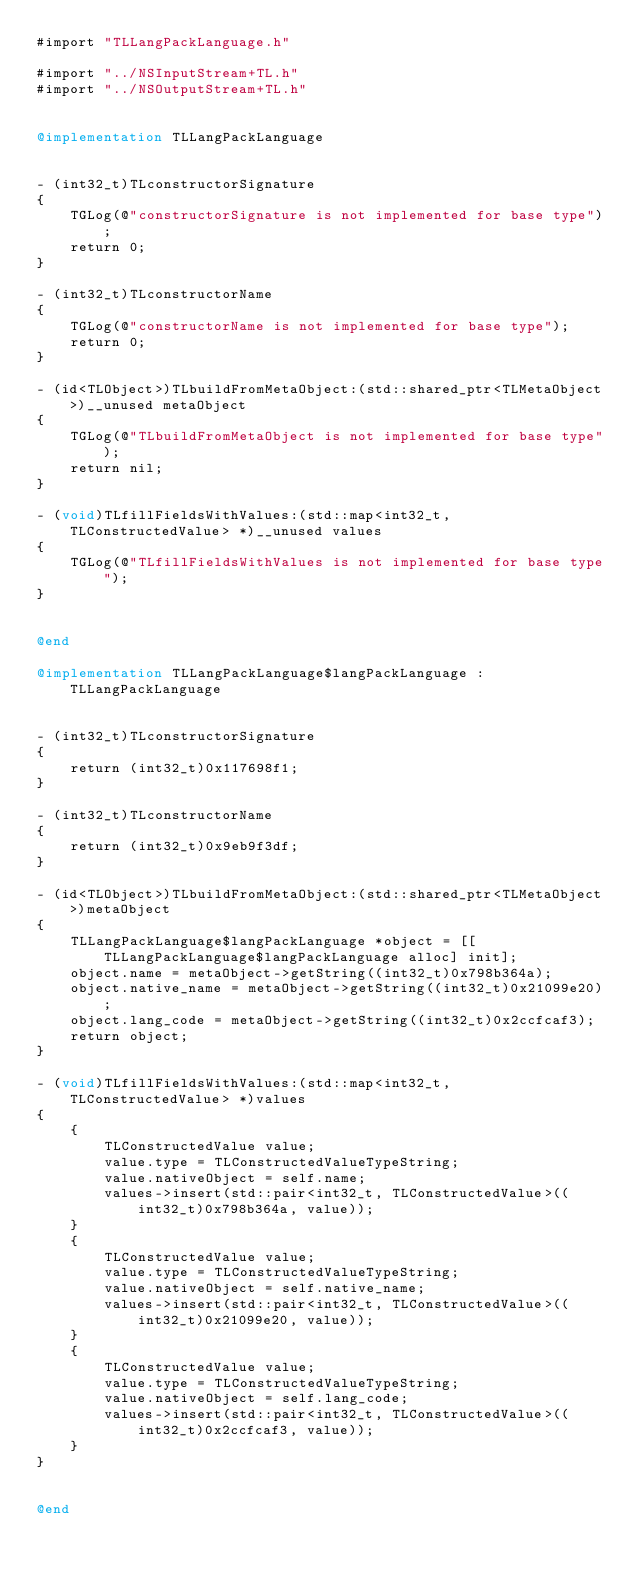Convert code to text. <code><loc_0><loc_0><loc_500><loc_500><_ObjectiveC_>#import "TLLangPackLanguage.h"

#import "../NSInputStream+TL.h"
#import "../NSOutputStream+TL.h"


@implementation TLLangPackLanguage


- (int32_t)TLconstructorSignature
{
    TGLog(@"constructorSignature is not implemented for base type");
    return 0;
}

- (int32_t)TLconstructorName
{
    TGLog(@"constructorName is not implemented for base type");
    return 0;
}

- (id<TLObject>)TLbuildFromMetaObject:(std::shared_ptr<TLMetaObject>)__unused metaObject
{
    TGLog(@"TLbuildFromMetaObject is not implemented for base type");
    return nil;
}

- (void)TLfillFieldsWithValues:(std::map<int32_t, TLConstructedValue> *)__unused values
{
    TGLog(@"TLfillFieldsWithValues is not implemented for base type");
}


@end

@implementation TLLangPackLanguage$langPackLanguage : TLLangPackLanguage


- (int32_t)TLconstructorSignature
{
    return (int32_t)0x117698f1;
}

- (int32_t)TLconstructorName
{
    return (int32_t)0x9eb9f3df;
}

- (id<TLObject>)TLbuildFromMetaObject:(std::shared_ptr<TLMetaObject>)metaObject
{
    TLLangPackLanguage$langPackLanguage *object = [[TLLangPackLanguage$langPackLanguage alloc] init];
    object.name = metaObject->getString((int32_t)0x798b364a);
    object.native_name = metaObject->getString((int32_t)0x21099e20);
    object.lang_code = metaObject->getString((int32_t)0x2ccfcaf3);
    return object;
}

- (void)TLfillFieldsWithValues:(std::map<int32_t, TLConstructedValue> *)values
{
    {
        TLConstructedValue value;
        value.type = TLConstructedValueTypeString;
        value.nativeObject = self.name;
        values->insert(std::pair<int32_t, TLConstructedValue>((int32_t)0x798b364a, value));
    }
    {
        TLConstructedValue value;
        value.type = TLConstructedValueTypeString;
        value.nativeObject = self.native_name;
        values->insert(std::pair<int32_t, TLConstructedValue>((int32_t)0x21099e20, value));
    }
    {
        TLConstructedValue value;
        value.type = TLConstructedValueTypeString;
        value.nativeObject = self.lang_code;
        values->insert(std::pair<int32_t, TLConstructedValue>((int32_t)0x2ccfcaf3, value));
    }
}


@end

</code> 